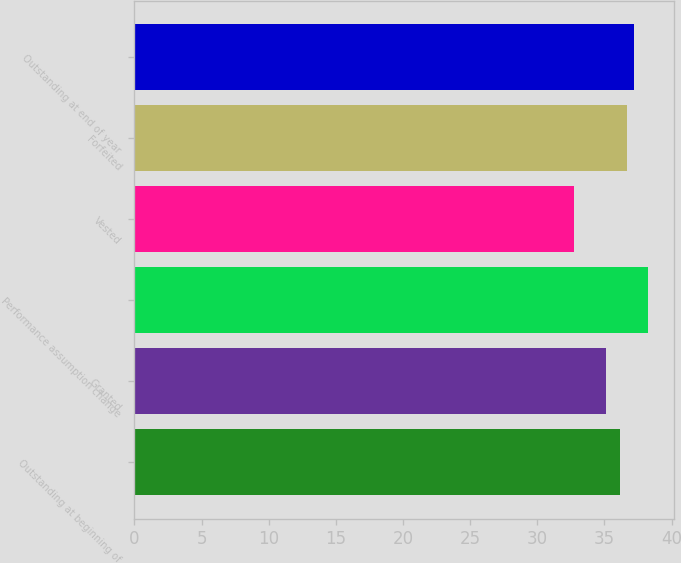Convert chart. <chart><loc_0><loc_0><loc_500><loc_500><bar_chart><fcel>Outstanding at beginning of<fcel>Granted<fcel>Performance assumption change<fcel>Vested<fcel>Forfeited<fcel>Outstanding at end of year<nl><fcel>36.13<fcel>35.09<fcel>38.26<fcel>32.74<fcel>36.68<fcel>37.23<nl></chart> 